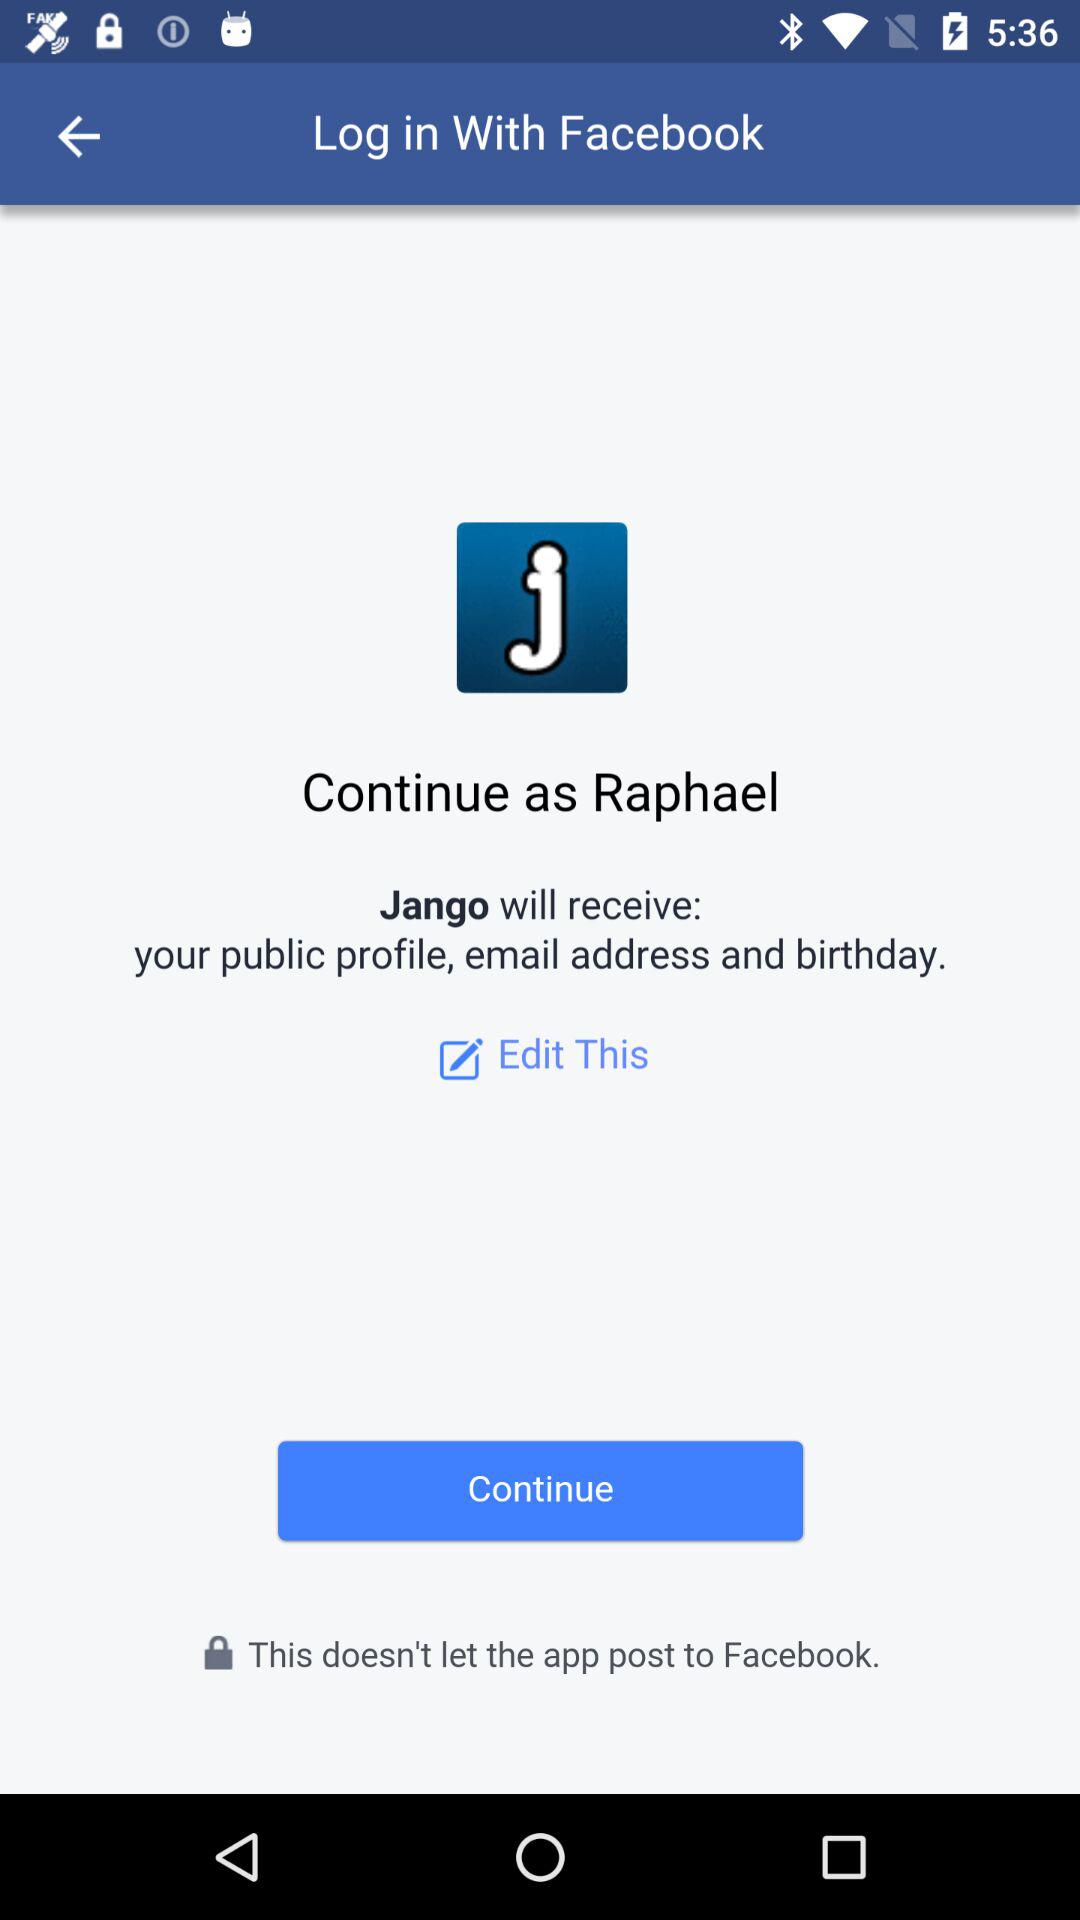Through what application can we log in? You can log in using Facebook. The screen shows the interface for logging in via Facebook, including options to continue as a specific user, in this case named Raphael, detailing what information (public profile, email address, and birthday) Jango will receive. 